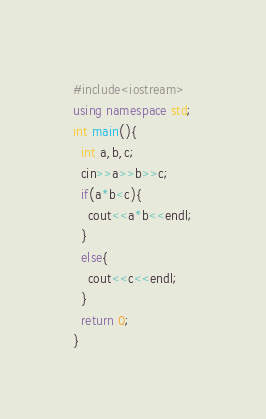<code> <loc_0><loc_0><loc_500><loc_500><_C++_>#include<iostream>
using namespace std;
int main(){
  int a,b,c;
  cin>>a>>b>>c;
  if(a*b<c){
    cout<<a*b<<endl;
  }
  else{
    cout<<c<<endl;
  }
  return 0;
}</code> 